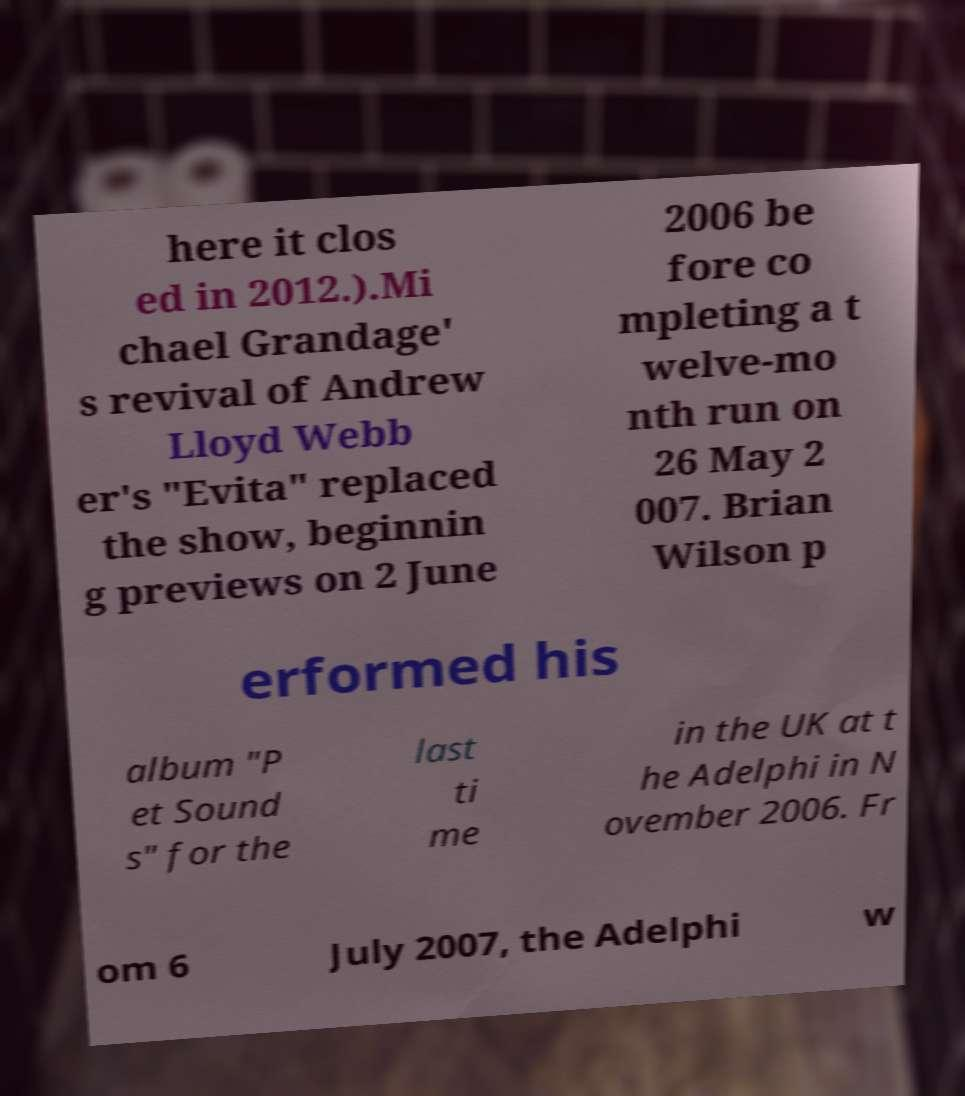What messages or text are displayed in this image? I need them in a readable, typed format. here it clos ed in 2012.).Mi chael Grandage' s revival of Andrew Lloyd Webb er's "Evita" replaced the show, beginnin g previews on 2 June 2006 be fore co mpleting a t welve-mo nth run on 26 May 2 007. Brian Wilson p erformed his album "P et Sound s" for the last ti me in the UK at t he Adelphi in N ovember 2006. Fr om 6 July 2007, the Adelphi w 